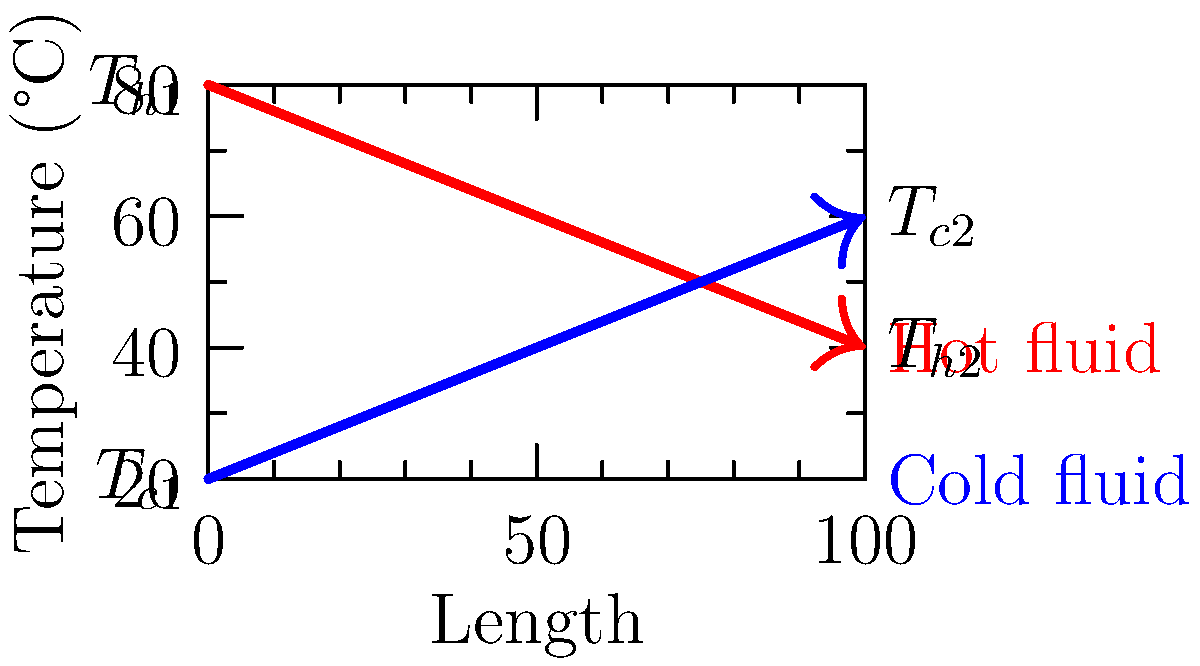In a countercurrent flow heat exchanger used to pre-heat a reactant for drug synthesis, the hot fluid enters at 80°C and exits at 40°C, while the cold fluid enters at 20°C and exits at 60°C. Given that the specific heat capacity of both fluids is 4.18 kJ/(kg·K) and the mass flow rate of the hot fluid is 2 kg/s, calculate the effectiveness of the heat exchanger. To calculate the effectiveness of the heat exchanger, we'll follow these steps:

1) First, calculate the actual heat transfer rate:
   $Q = m_h \cdot c_p \cdot (T_{h1} - T_{h2})$
   $Q = 2 \text{ kg/s} \cdot 4.18 \text{ kJ/(kg·K)} \cdot (80°C - 40°C) = 334.4 \text{ kW}$

2) Determine the maximum possible heat transfer rate:
   $Q_{max} = C_{min} \cdot (T_{h1} - T_{c1})$
   where $C_{min}$ is the smaller of $C_h$ and $C_c$

3) Calculate $C_h$:
   $C_h = m_h \cdot c_p = 2 \text{ kg/s} \cdot 4.18 \text{ kJ/(kg·K)} = 8.36 \text{ kW/K}$

4) Calculate $C_c$:
   $C_c = m_c \cdot c_p = \frac{Q}{T_{c2} - T_{c1}} = \frac{334.4 \text{ kW}}{60°C - 20°C} = 8.36 \text{ kW/K}$

5) Since $C_h = C_c$, use either for $C_{min}$:
   $Q_{max} = 8.36 \text{ kW/K} \cdot (80°C - 20°C) = 501.6 \text{ kW}$

6) Calculate effectiveness:
   $\varepsilon = \frac{Q}{Q_{max}} = \frac{334.4 \text{ kW}}{501.6 \text{ kW}} = 0.6667$ or $66.67\%$
Answer: 66.67% 